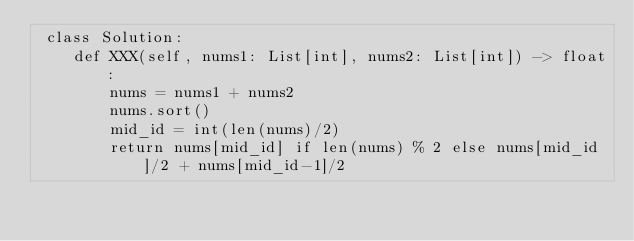Convert code to text. <code><loc_0><loc_0><loc_500><loc_500><_Python_> class Solution:
    def XXX(self, nums1: List[int], nums2: List[int]) -> float:
        nums = nums1 + nums2
        nums.sort()
        mid_id = int(len(nums)/2)
        return nums[mid_id] if len(nums) % 2 else nums[mid_id]/2 + nums[mid_id-1]/2

</code> 